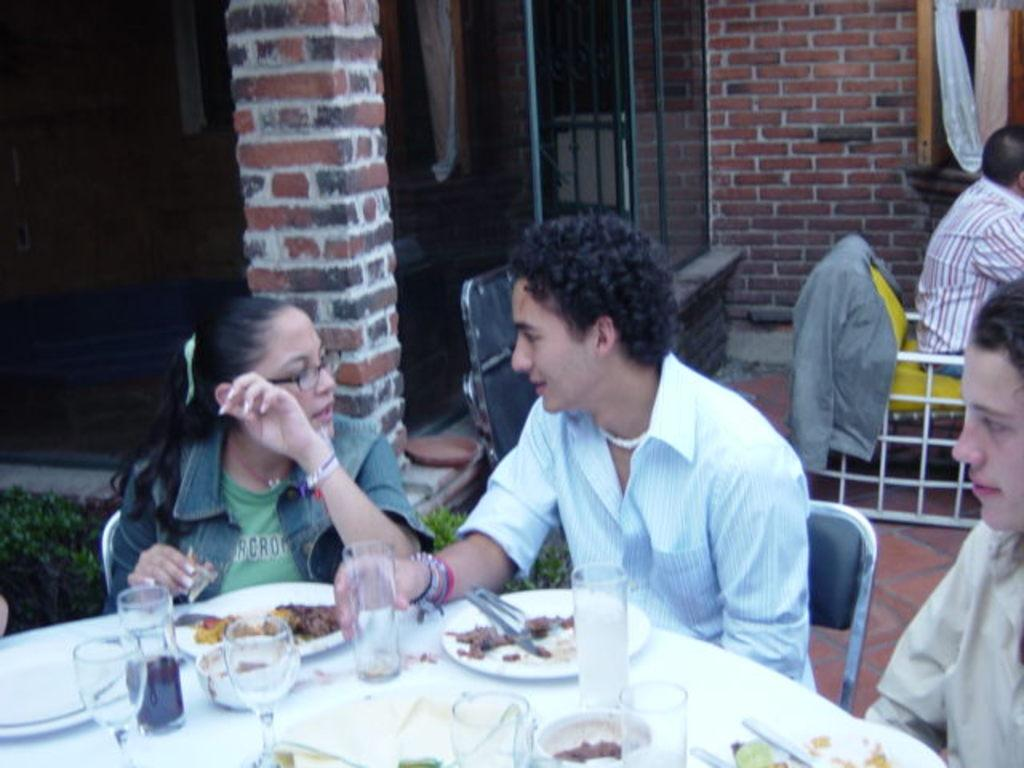What are the people in the image doing? The people are sitting on chairs and having food. What is on the table in front of the people? There is a table in front of the people with glasses and plates on it. What type of building can be seen behind the people? There is a building made of bricks behind the people. What is the fact about the brake system of the country in the image? There is no information about a brake system or a country in the image. The image features people sitting at a table with food, glasses, and plates, and a brick building in the background. 